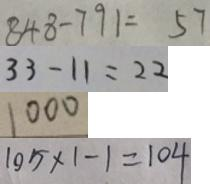<formula> <loc_0><loc_0><loc_500><loc_500>8 4 8 - 7 9 1 = 5 7 
 3 3 - 1 1 = 2 2 
 1 0 0 0 
 1 0 5 \times 1 - 1 = 1 0 4</formula> 